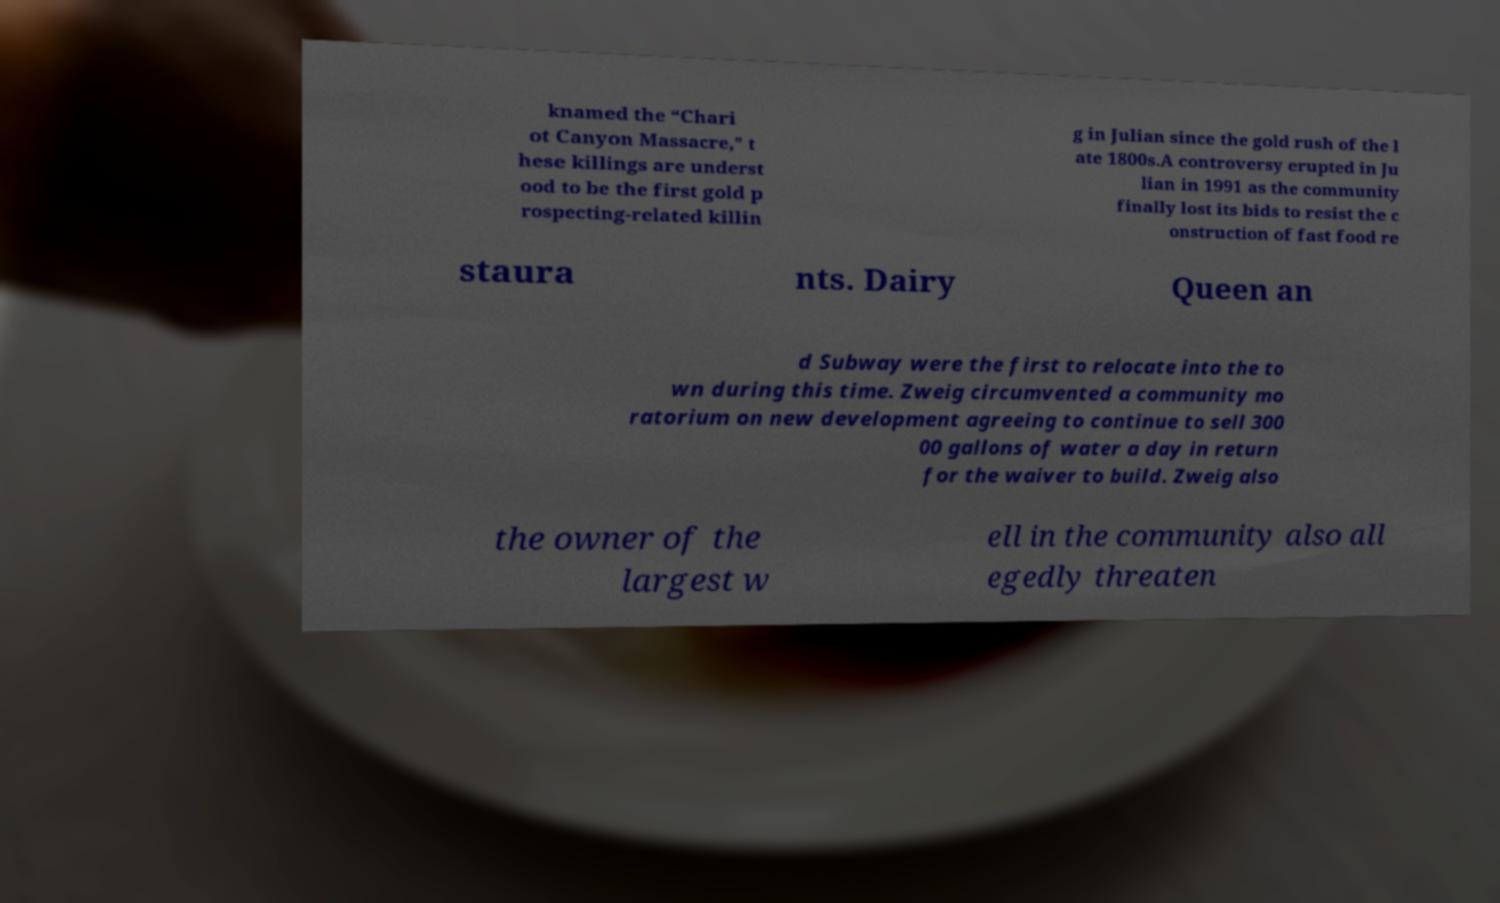Please identify and transcribe the text found in this image. knamed the “Chari ot Canyon Massacre,” t hese killings are underst ood to be the first gold p rospecting-related killin g in Julian since the gold rush of the l ate 1800s.A controversy erupted in Ju lian in 1991 as the community finally lost its bids to resist the c onstruction of fast food re staura nts. Dairy Queen an d Subway were the first to relocate into the to wn during this time. Zweig circumvented a community mo ratorium on new development agreeing to continue to sell 300 00 gallons of water a day in return for the waiver to build. Zweig also the owner of the largest w ell in the community also all egedly threaten 